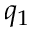<formula> <loc_0><loc_0><loc_500><loc_500>q _ { 1 }</formula> 